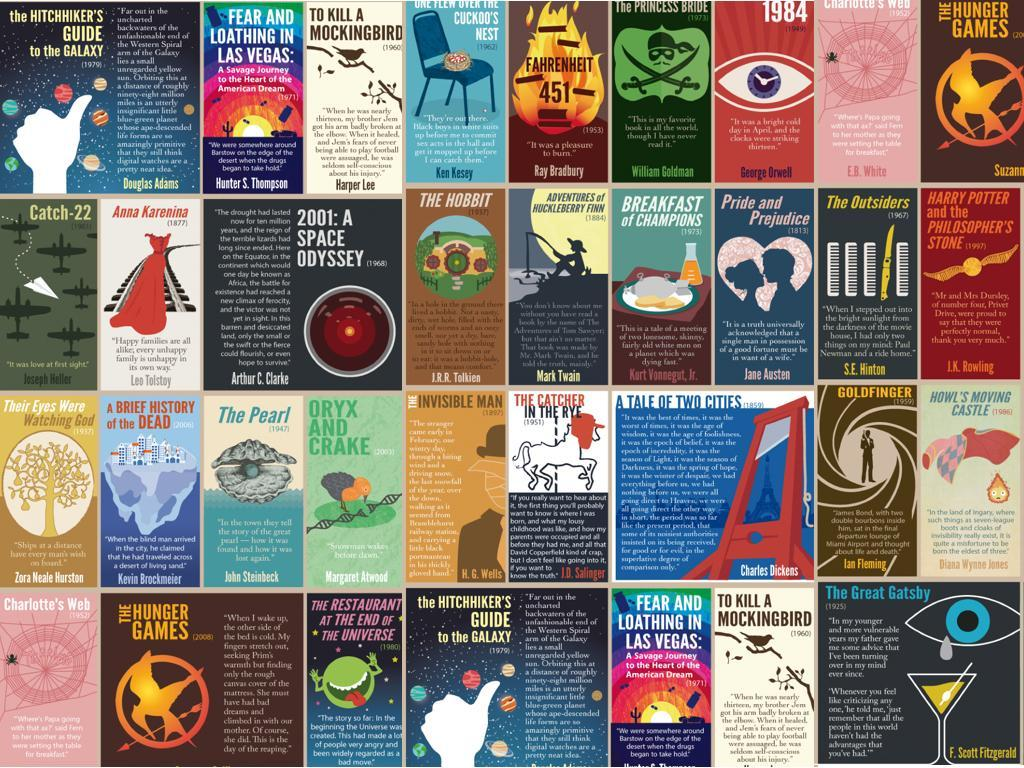Who is the author of "Pride and Prejudice"?
Answer the question with a short phrase. Jane Austen Who is the author of "Goldfinger"? Ian Fleming By whom was the book "The Great Gatsby" written? F. Scott Fitzgerald Who wrote the book named "The Hobbit"? J.R.R. Tolkien Who is the author of the book "To kill a mockingbird"? Harper Lee Who wrote the book "Fahrenheit 451"? Ray Bradbury Which book written by Mark Twain is shown in this infographic? Adventures of Huckleberry Finn Who wrote the book "Anna Karenina"? Leo Tolstoy Which book written by J.K. Rowling is shown in the infographic? Harry Potter and the Philosopher's Stone Which book written by Charles Dickens has been featured in this infographic? A tale of two cities 